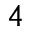Convert formula to latex. <formula><loc_0><loc_0><loc_500><loc_500>^ { 4 }</formula> 